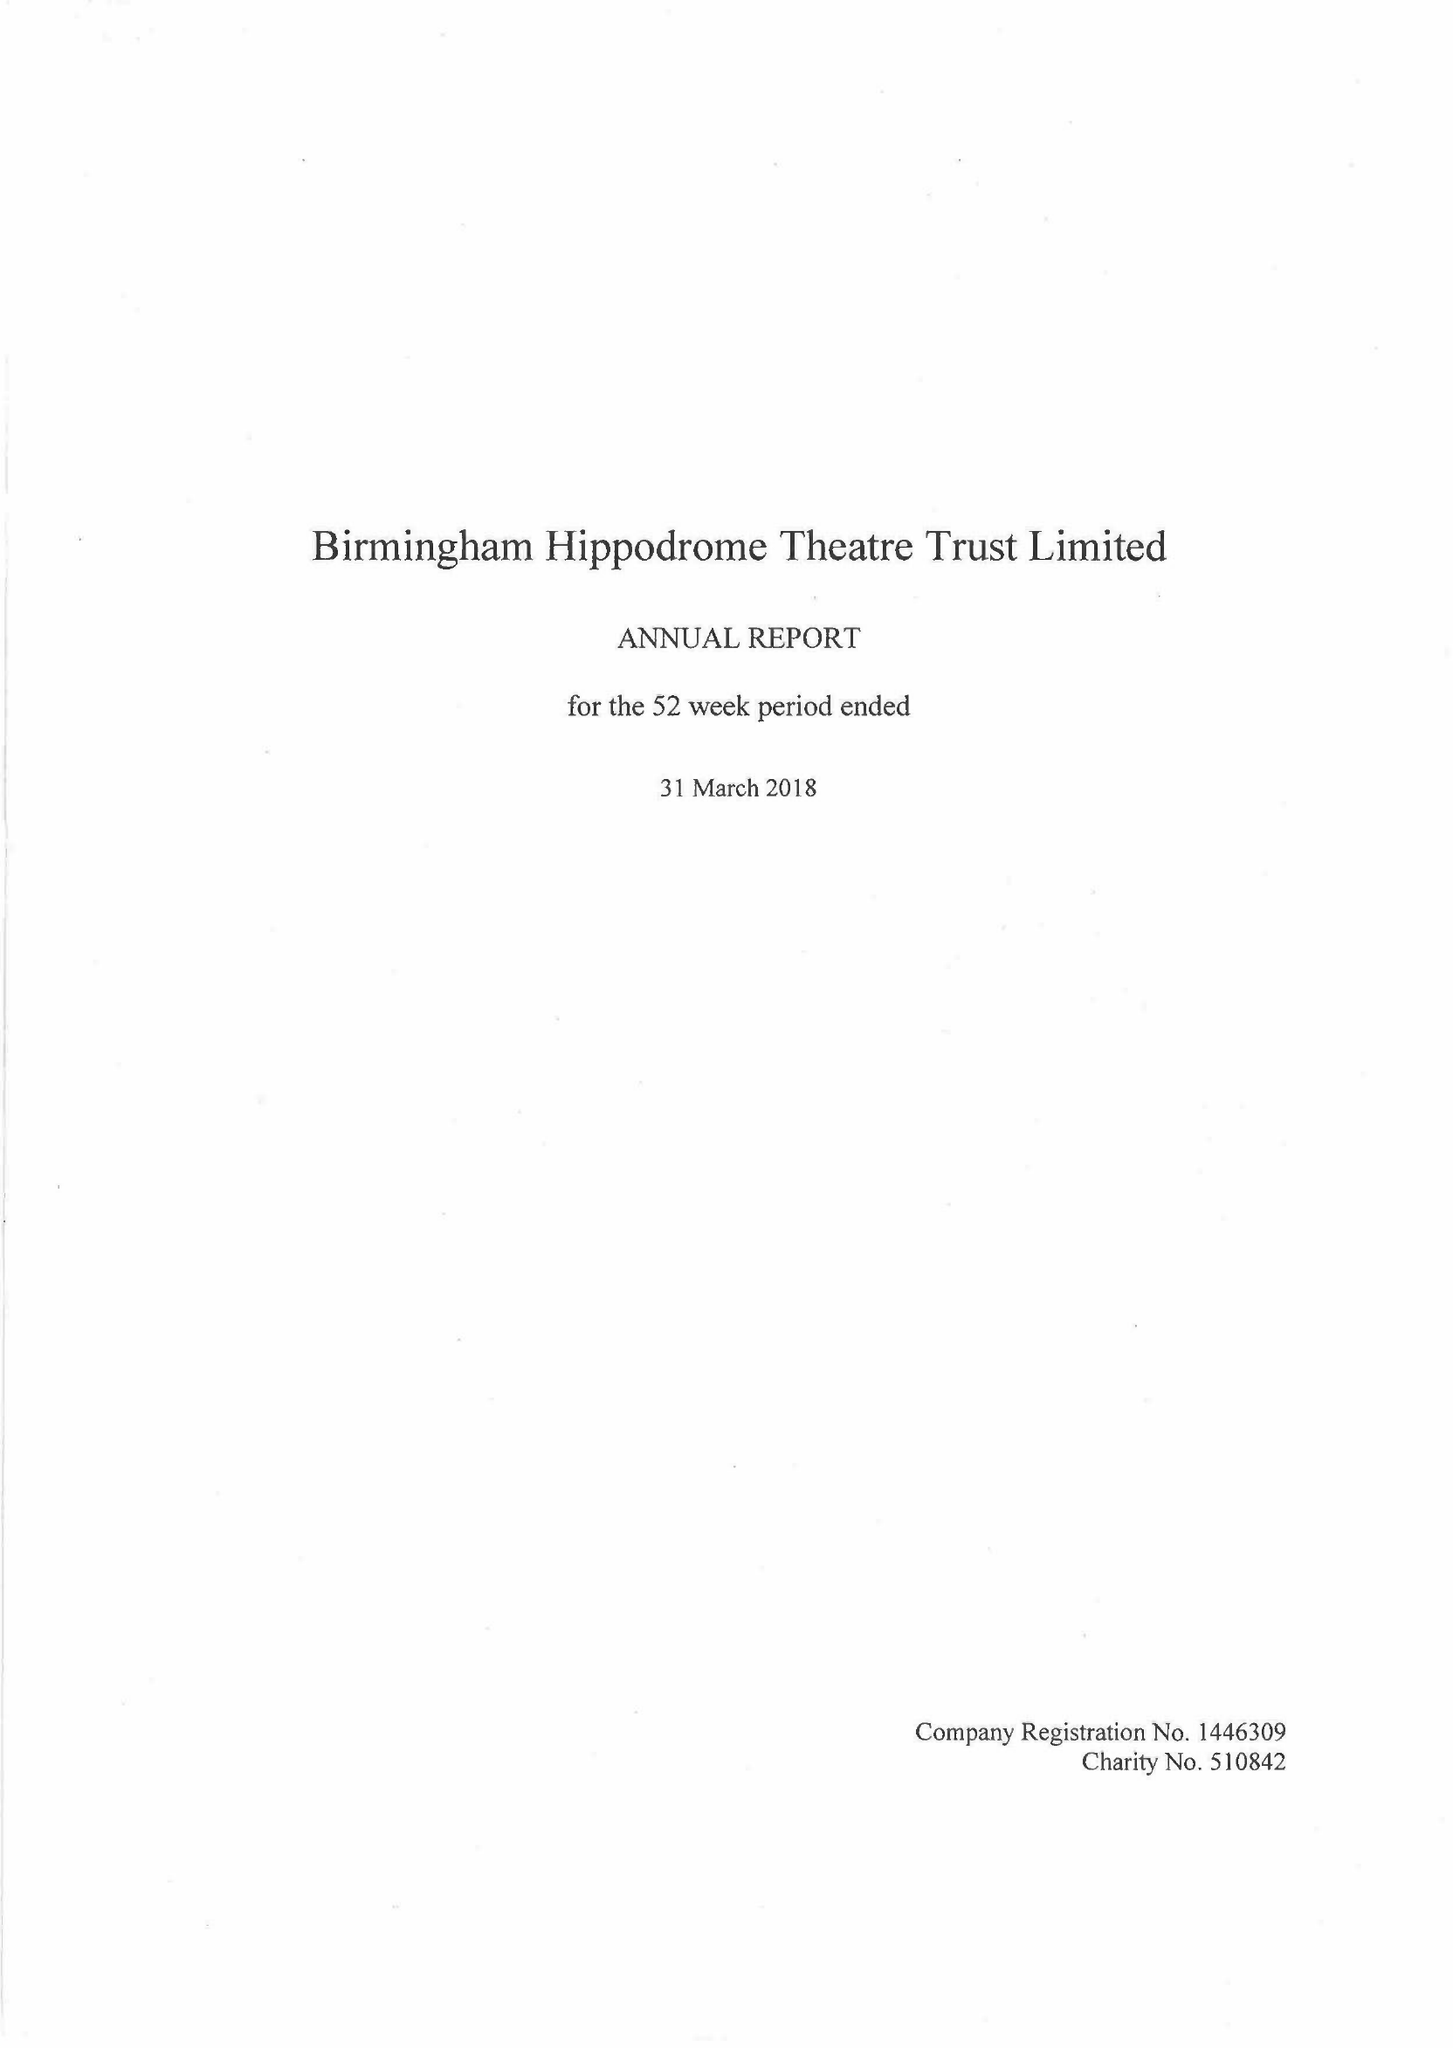What is the value for the charity_number?
Answer the question using a single word or phrase. 510842 